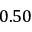<formula> <loc_0><loc_0><loc_500><loc_500>0 . 5 0</formula> 